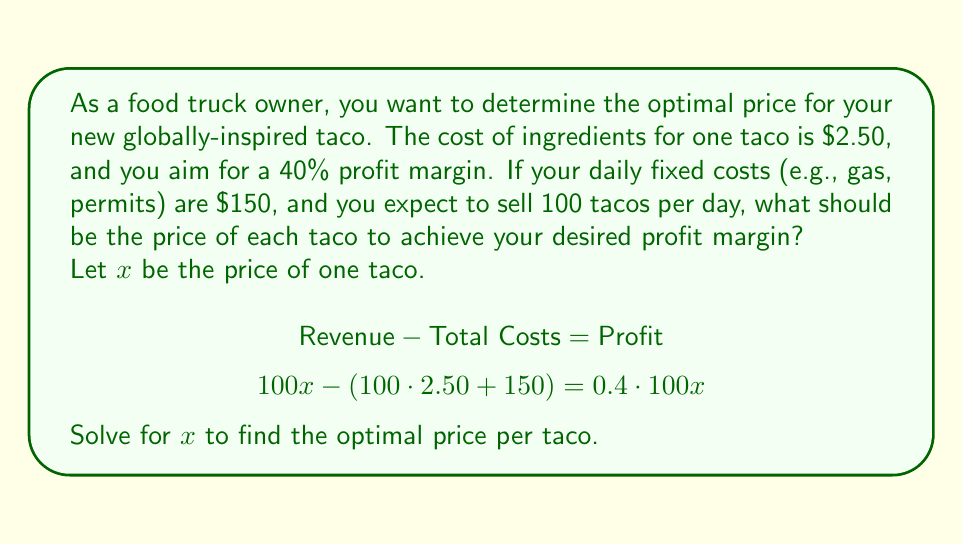Can you solve this math problem? Let's approach this step-by-step:

1) First, let's set up our equation based on the given information:
   $$100x - (100 \cdot 2.50 + 150) = 0.4 \cdot 100x$$

2) Simplify the left side of the equation:
   $$100x - 250 - 150 = 0.4 \cdot 100x$$
   $$100x - 400 = 40x$$

3) Subtract 40x from both sides:
   $$60x - 400 = 0$$

4) Add 400 to both sides:
   $$60x = 400$$

5) Divide both sides by 60:
   $$x = \frac{400}{60} = \frac{20}{3} \approx 6.67$$

Therefore, to achieve a 40% profit margin, you should price each taco at $\frac{20}{3}$ or approximately $6.67.

Let's verify:
- Revenue: $100 \cdot 6.67 = 667$
- Costs: $100 \cdot 2.50 + 150 = 400$
- Profit: $667 - 400 = 267$
- Profit Margin: $\frac{267}{667} \approx 0.40$ or 40%

This confirms that the calculated price achieves the desired 40% profit margin.
Answer: The optimal price for each taco should be $\frac{20}{3}$ or approximately $6.67. 